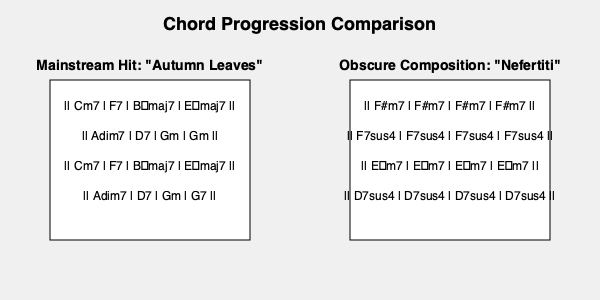Analyze the chord progressions of the mainstream jazz hit "Autumn Leaves" and the more obscure composition "Nefertiti" by Wayne Shorter. How does the harmonic approach in "Nefertiti" challenge traditional jazz conventions, and what implications might this have for improvisation? To answer this question, let's break down the chord progressions and analyze their differences:

1. "Autumn Leaves" progression:
   - Follows a typical ii-V-I progression in two keys (B♭ and G minor)
   - Uses functional harmony with clear resolutions
   - Employs a variety of chord qualities (m7, 7, maj7, dim7)
   - Has a clear 32-bar AABA form

2. "Nefertiti" progression:
   - Uses static harmony with each chord lasting for four measures
   - Employs only two chord qualities (m7 and 7sus4)
   - Lacks traditional functional harmony and resolutions
   - Has an unconventional 16-bar form

3. Challenges to traditional jazz conventions in "Nefertiti":
   a) Static harmony: Breaks away from the constant chord changes typical in bebop and earlier jazz styles
   b) Lack of functional harmony: Doesn't follow expected harmonic resolutions
   c) Limited chord qualities: Creates a more modal approach to harmony
   d) Unconventional form: Deviates from the standard 32-bar AABA form

4. Implications for improvisation:
   a) Encourages modal improvisation over functional chord-based improvisation
   b) Allows for more freedom in note choice due to the static harmony
   c) Challenges musicians to create interest through other means (rhythm, texture, etc.) rather than relying on harmonic movement
   d) Shifts focus from "playing the changes" to exploring the sonic possibilities within each chord

5. Historical context:
   - "Nefertiti" represents the avant-garde and post-bop movements of the 1960s
   - Reflects a shift towards more experimental and freer forms of jazz
   - Challenges listeners and musicians to reconsider what constitutes jazz harmony and form

This approach in "Nefertiti" exemplifies the innovative spirit of musicians like Wayne Shorter, who pushed the boundaries of jazz composition and improvisation, paving the way for new forms of expression within the genre.
Answer: "Nefertiti" uses static, modal harmony and an unconventional form, challenging traditional functional harmony and encouraging freer, more exploratory improvisation. 